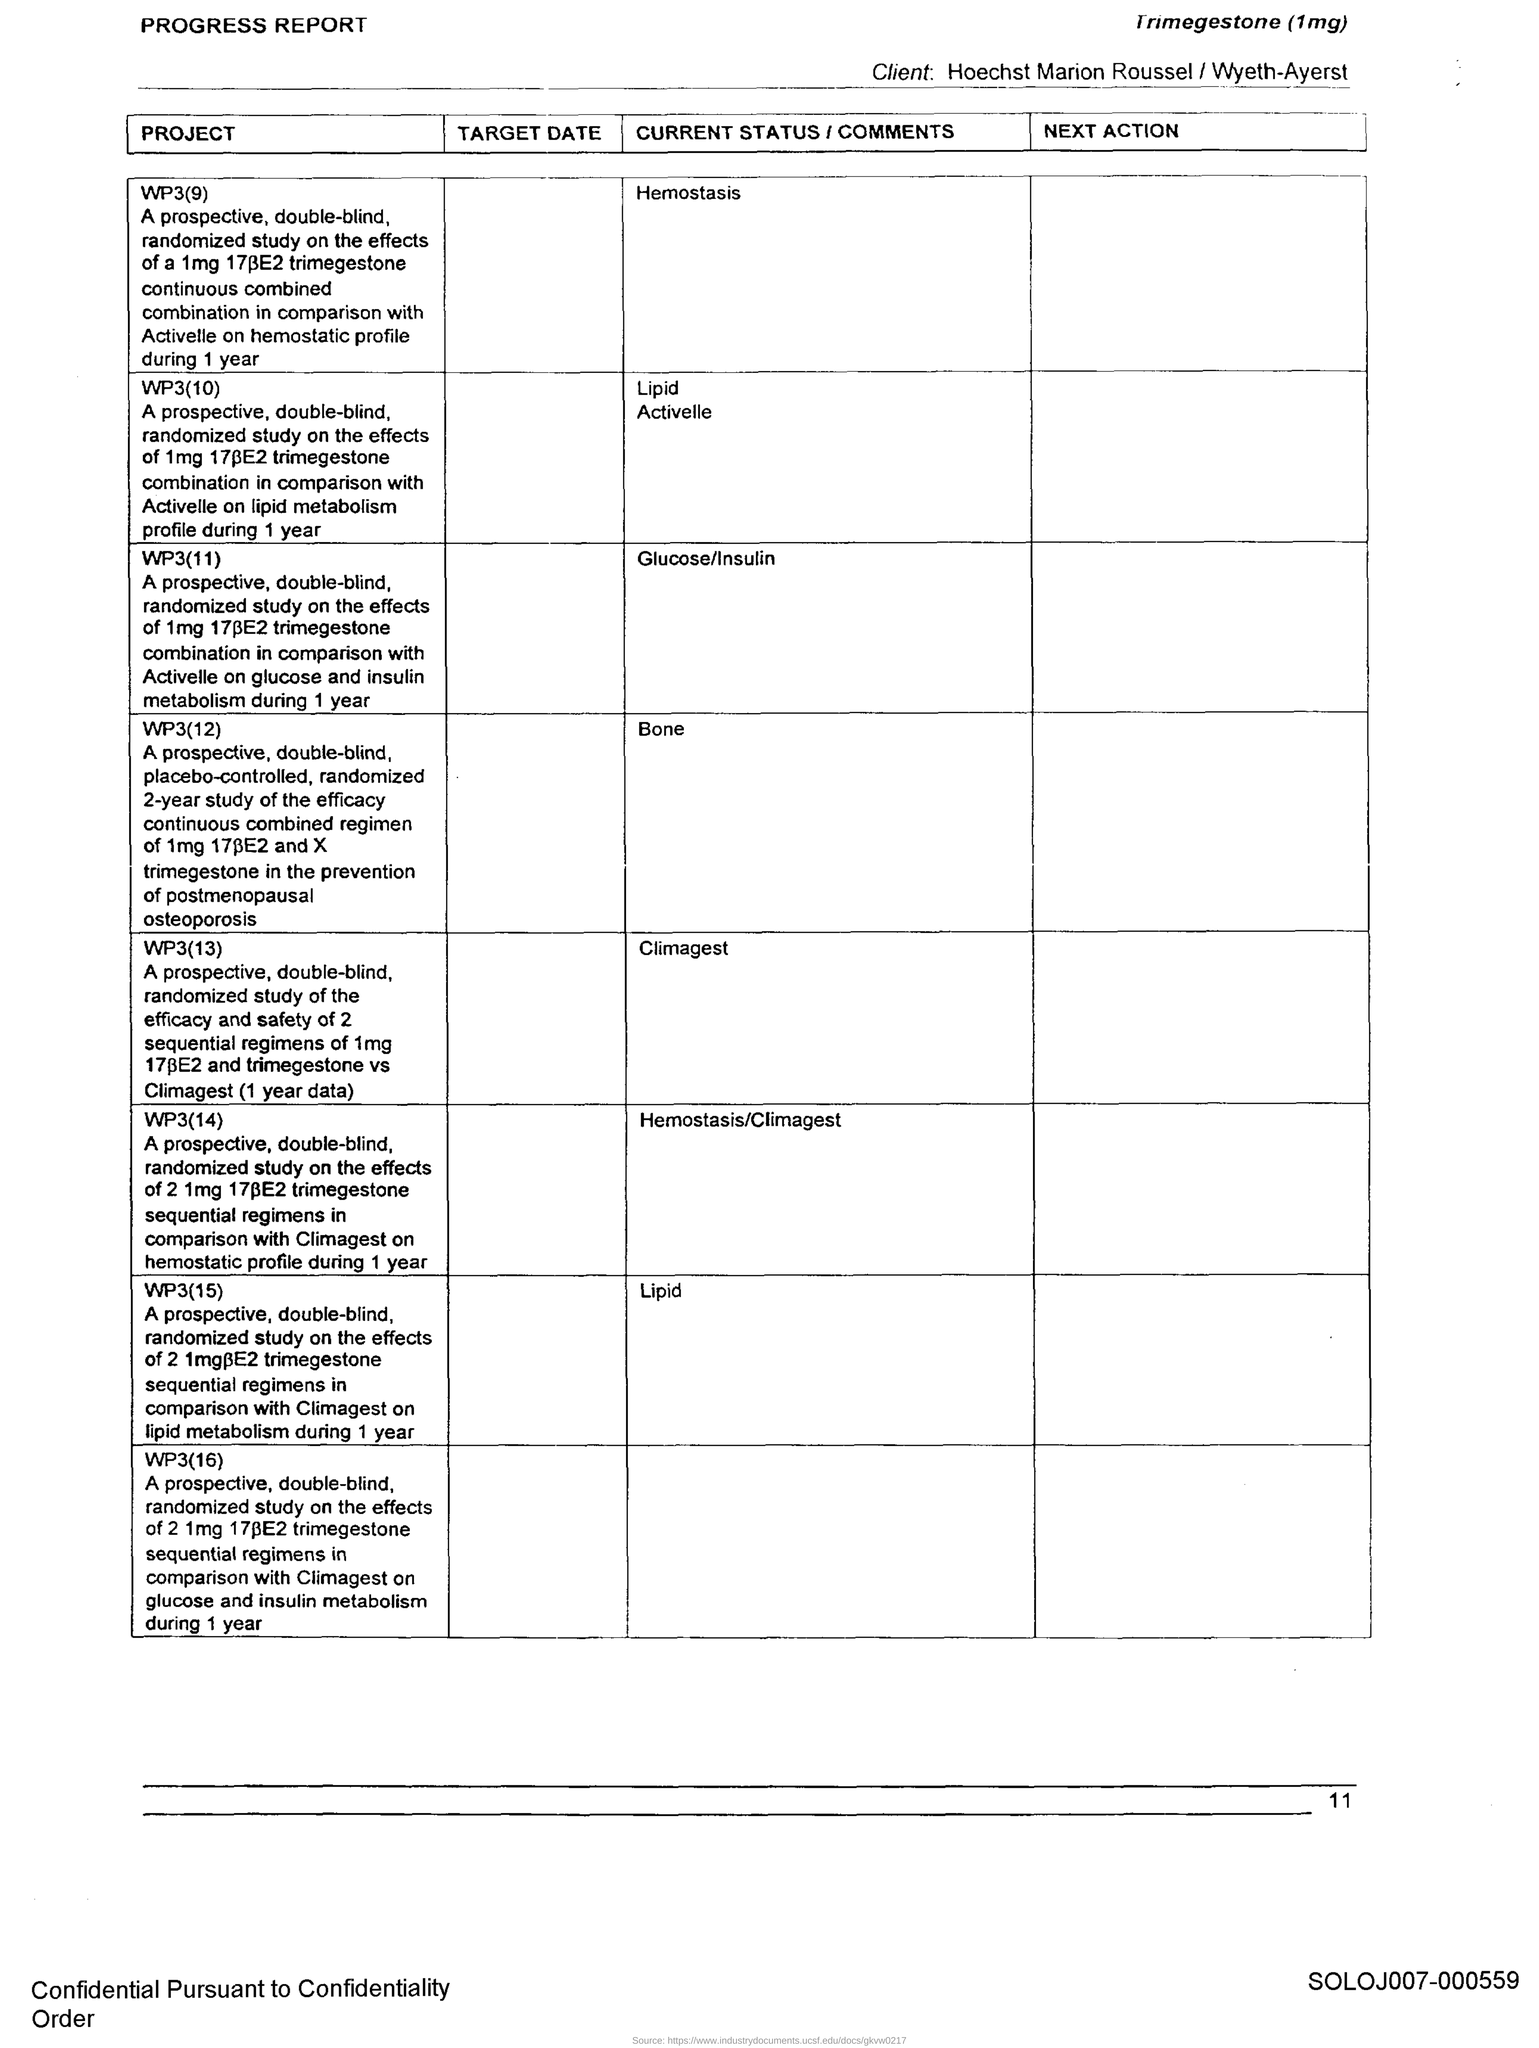List a handful of essential elements in this visual. The current status of PROJECT WP3(13) is unknown, as the Climagest team has not provided any updates. The current status of PROJECT WP3(9) is focused on hemostasis. 